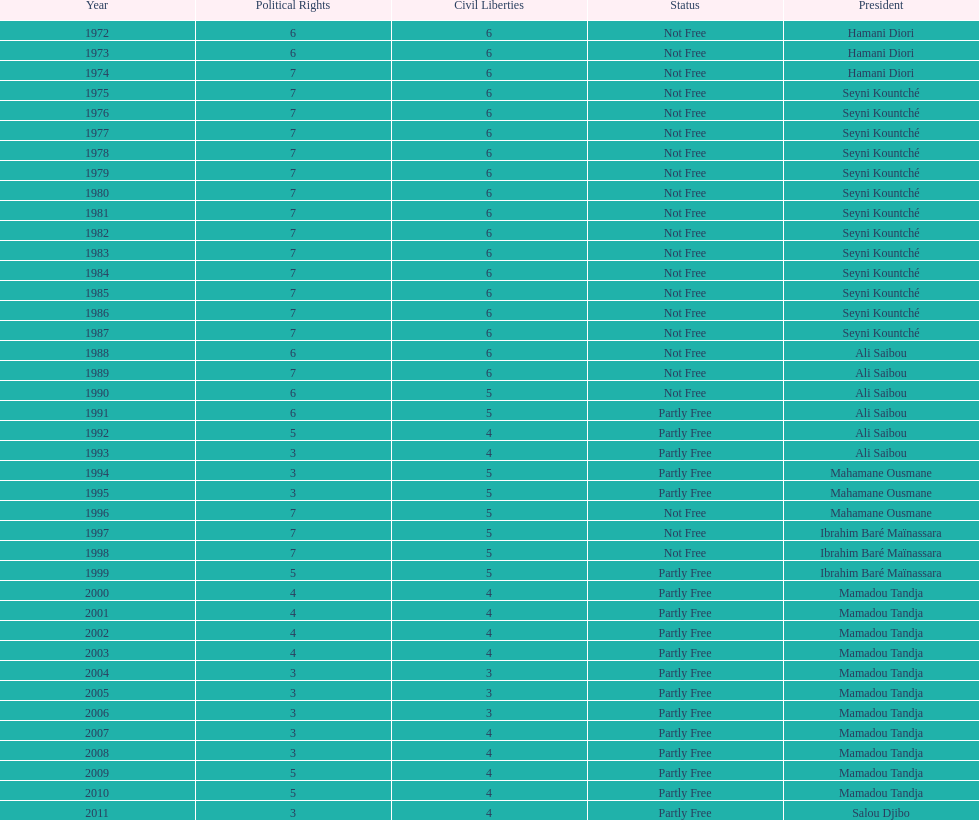How many times was the political rights listed as seven? 18. Would you mind parsing the complete table? {'header': ['Year', 'Political Rights', 'Civil Liberties', 'Status', 'President'], 'rows': [['1972', '6', '6', 'Not Free', 'Hamani Diori'], ['1973', '6', '6', 'Not Free', 'Hamani Diori'], ['1974', '7', '6', 'Not Free', 'Hamani Diori'], ['1975', '7', '6', 'Not Free', 'Seyni Kountché'], ['1976', '7', '6', 'Not Free', 'Seyni Kountché'], ['1977', '7', '6', 'Not Free', 'Seyni Kountché'], ['1978', '7', '6', 'Not Free', 'Seyni Kountché'], ['1979', '7', '6', 'Not Free', 'Seyni Kountché'], ['1980', '7', '6', 'Not Free', 'Seyni Kountché'], ['1981', '7', '6', 'Not Free', 'Seyni Kountché'], ['1982', '7', '6', 'Not Free', 'Seyni Kountché'], ['1983', '7', '6', 'Not Free', 'Seyni Kountché'], ['1984', '7', '6', 'Not Free', 'Seyni Kountché'], ['1985', '7', '6', 'Not Free', 'Seyni Kountché'], ['1986', '7', '6', 'Not Free', 'Seyni Kountché'], ['1987', '7', '6', 'Not Free', 'Seyni Kountché'], ['1988', '6', '6', 'Not Free', 'Ali Saibou'], ['1989', '7', '6', 'Not Free', 'Ali Saibou'], ['1990', '6', '5', 'Not Free', 'Ali Saibou'], ['1991', '6', '5', 'Partly Free', 'Ali Saibou'], ['1992', '5', '4', 'Partly Free', 'Ali Saibou'], ['1993', '3', '4', 'Partly Free', 'Ali Saibou'], ['1994', '3', '5', 'Partly Free', 'Mahamane Ousmane'], ['1995', '3', '5', 'Partly Free', 'Mahamane Ousmane'], ['1996', '7', '5', 'Not Free', 'Mahamane Ousmane'], ['1997', '7', '5', 'Not Free', 'Ibrahim Baré Maïnassara'], ['1998', '7', '5', 'Not Free', 'Ibrahim Baré Maïnassara'], ['1999', '5', '5', 'Partly Free', 'Ibrahim Baré Maïnassara'], ['2000', '4', '4', 'Partly Free', 'Mamadou Tandja'], ['2001', '4', '4', 'Partly Free', 'Mamadou Tandja'], ['2002', '4', '4', 'Partly Free', 'Mamadou Tandja'], ['2003', '4', '4', 'Partly Free', 'Mamadou Tandja'], ['2004', '3', '3', 'Partly Free', 'Mamadou Tandja'], ['2005', '3', '3', 'Partly Free', 'Mamadou Tandja'], ['2006', '3', '3', 'Partly Free', 'Mamadou Tandja'], ['2007', '3', '4', 'Partly Free', 'Mamadou Tandja'], ['2008', '3', '4', 'Partly Free', 'Mamadou Tandja'], ['2009', '5', '4', 'Partly Free', 'Mamadou Tandja'], ['2010', '5', '4', 'Partly Free', 'Mamadou Tandja'], ['2011', '3', '4', 'Partly Free', 'Salou Djibo']]} 